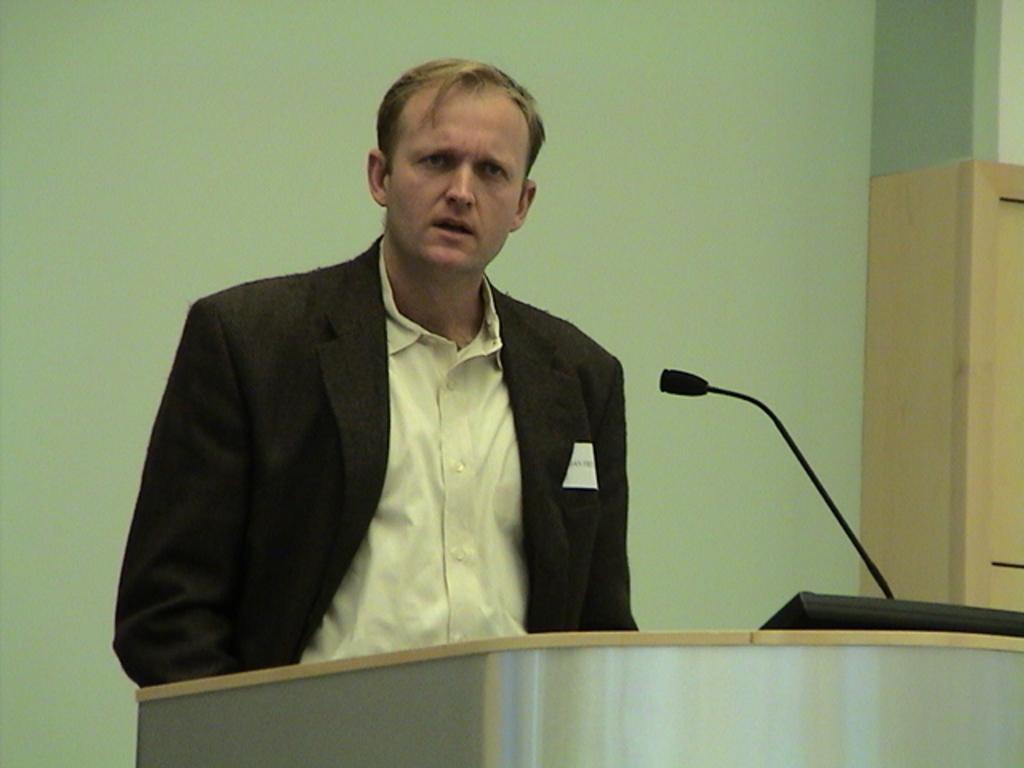Could you give a brief overview of what you see in this image? In this picture I can see a man is standing in front of a podium. The man is wearing black color coat and shirt. Here I can see a microphone on the podium. In the background I can see a wall. 